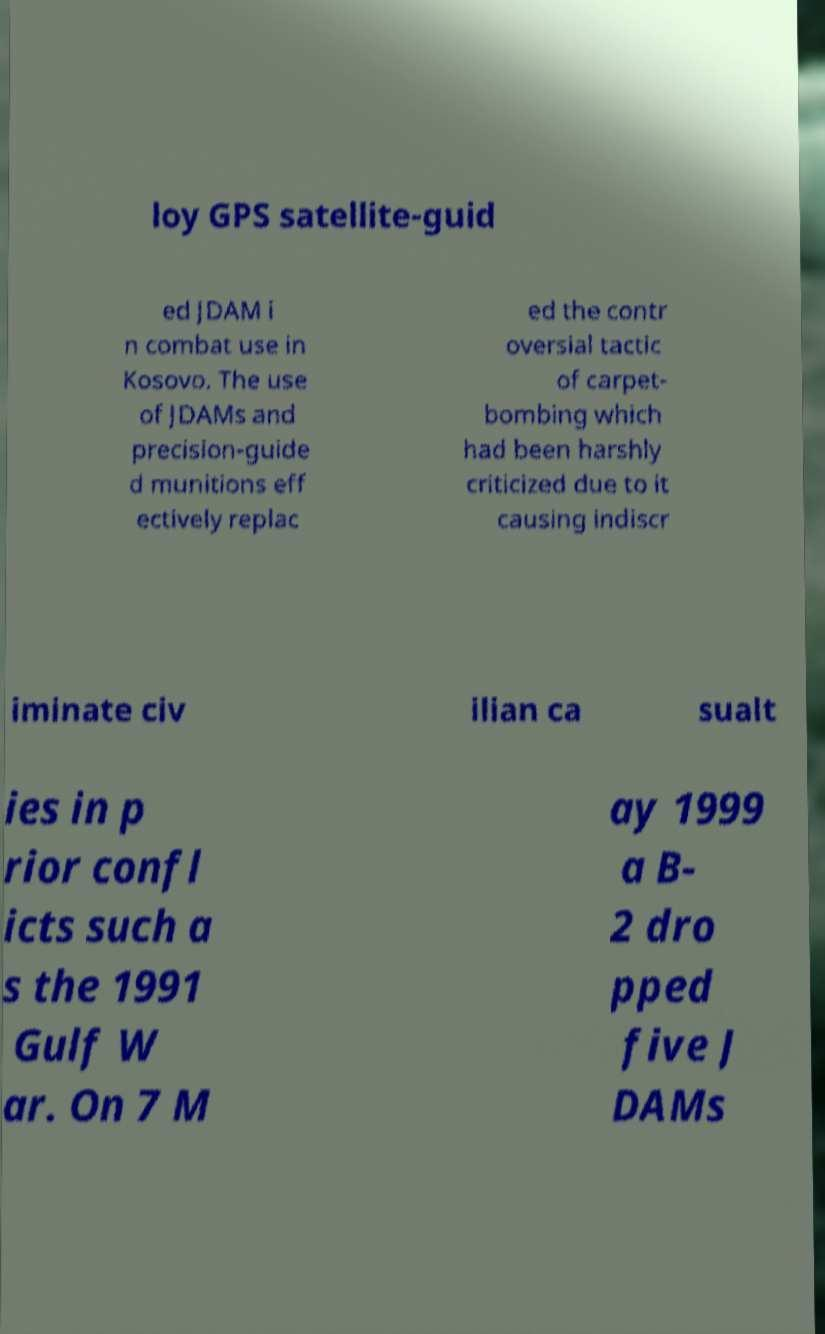For documentation purposes, I need the text within this image transcribed. Could you provide that? loy GPS satellite-guid ed JDAM i n combat use in Kosovo. The use of JDAMs and precision-guide d munitions eff ectively replac ed the contr oversial tactic of carpet- bombing which had been harshly criticized due to it causing indiscr iminate civ ilian ca sualt ies in p rior confl icts such a s the 1991 Gulf W ar. On 7 M ay 1999 a B- 2 dro pped five J DAMs 